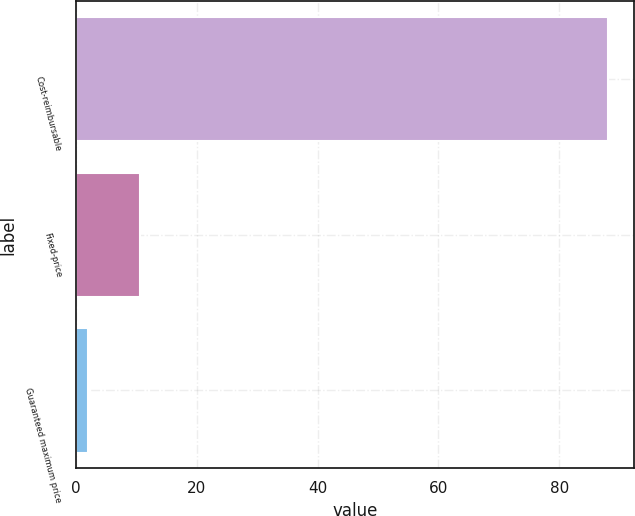Convert chart to OTSL. <chart><loc_0><loc_0><loc_500><loc_500><bar_chart><fcel>Cost-reimbursable<fcel>Fixed-price<fcel>Guaranteed maximum price<nl><fcel>88<fcel>10.6<fcel>2<nl></chart> 